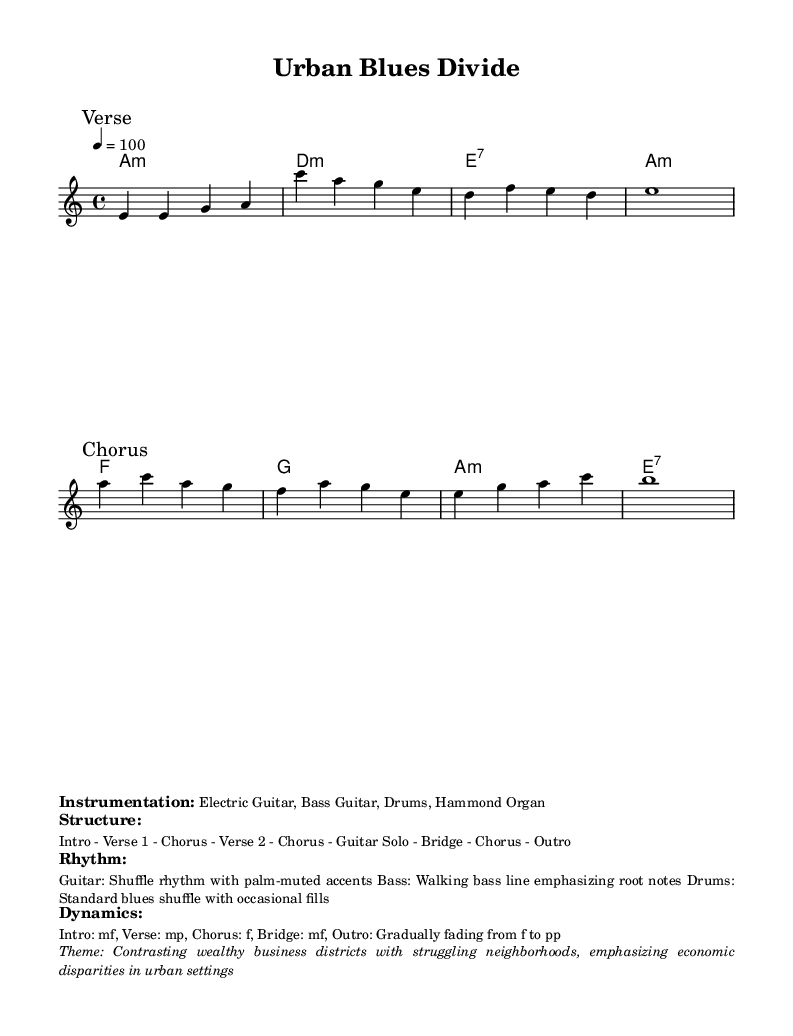What is the key signature of this music? The key signature is A minor, indicated by no sharps or flats, and is confirmed by the global setting in the code.
Answer: A minor What is the time signature used in this piece? The time signature is 4/4, as specified in the global settings of the code.
Answer: 4/4 What is the tempo marking for the piece? The tempo marking is given as 4 = 100, indicating the beats per minute.
Answer: 100 How many verses are there in the structure of the song? The structure listed indicates two verses, labeled in sequence as "Verse 1" and "Verse 2".
Answer: Two What is the primary theme of the song? The theme describes economic disparities between wealthy business districts and struggling neighborhoods, as stated in the markup section.
Answer: Economic disparities What rhythmic style is used on the guitar? The guitar features a shuffle rhythm with palm-muted accents, which is detailed in the markup section regarding rhythm.
Answer: Shuffle rhythm What instruments are included in the instrumentation? The piece includes Electric Guitar, Bass Guitar, Drums, and Hammond Organ, as outlined in the instrumentation portion of the markup.
Answer: Electric Guitar, Bass Guitar, Drums, Hammond Organ 